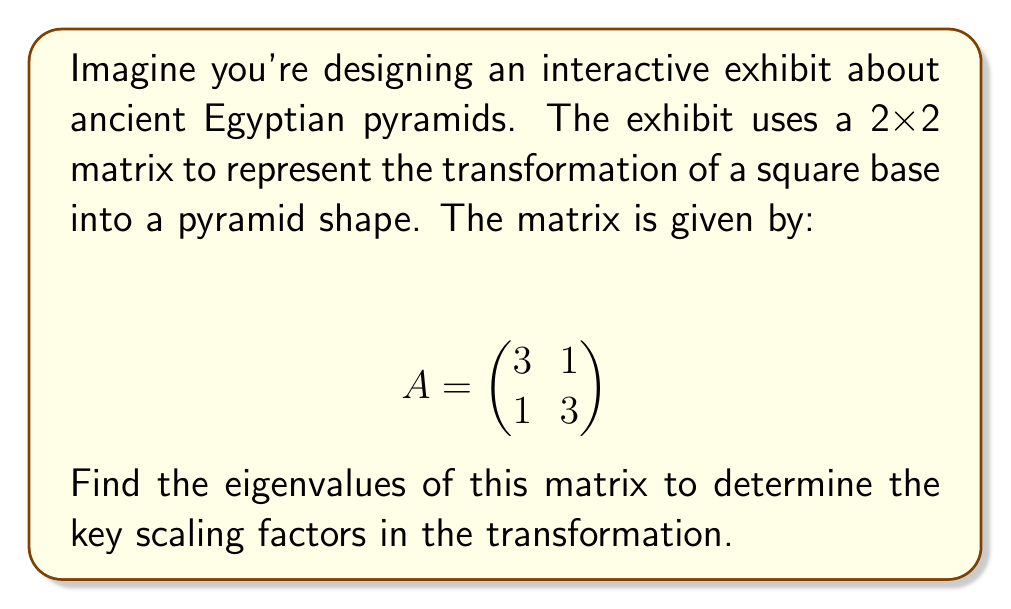Show me your answer to this math problem. To find the eigenvalues of the 2x2 matrix A, we follow these steps:

1) The characteristic equation for eigenvalues is given by:
   $$ det(A - \lambda I) = 0 $$
   where $\lambda$ represents the eigenvalues and I is the 2x2 identity matrix.

2) Expand the equation:
   $$ det\begin{pmatrix} 3-\lambda & 1 \\ 1 & 3-\lambda \end{pmatrix} = 0 $$

3) Calculate the determinant:
   $$ (3-\lambda)(3-\lambda) - 1 \cdot 1 = 0 $$

4) Simplify:
   $$ (3-\lambda)^2 - 1 = 0 $$
   $$ 9 - 6\lambda + \lambda^2 - 1 = 0 $$
   $$ \lambda^2 - 6\lambda + 8 = 0 $$

5) This is a quadratic equation. We can solve it using the quadratic formula:
   $$ \lambda = \frac{-b \pm \sqrt{b^2 - 4ac}}{2a} $$
   where $a=1$, $b=-6$, and $c=8$

6) Substitute into the formula:
   $$ \lambda = \frac{6 \pm \sqrt{36 - 32}}{2} = \frac{6 \pm \sqrt{4}}{2} = \frac{6 \pm 2}{2} $$

7) Solve:
   $$ \lambda_1 = \frac{6 + 2}{2} = 4 $$
   $$ \lambda_2 = \frac{6 - 2}{2} = 2 $$

Therefore, the eigenvalues are 4 and 2.
Answer: $\lambda_1 = 4$, $\lambda_2 = 2$ 